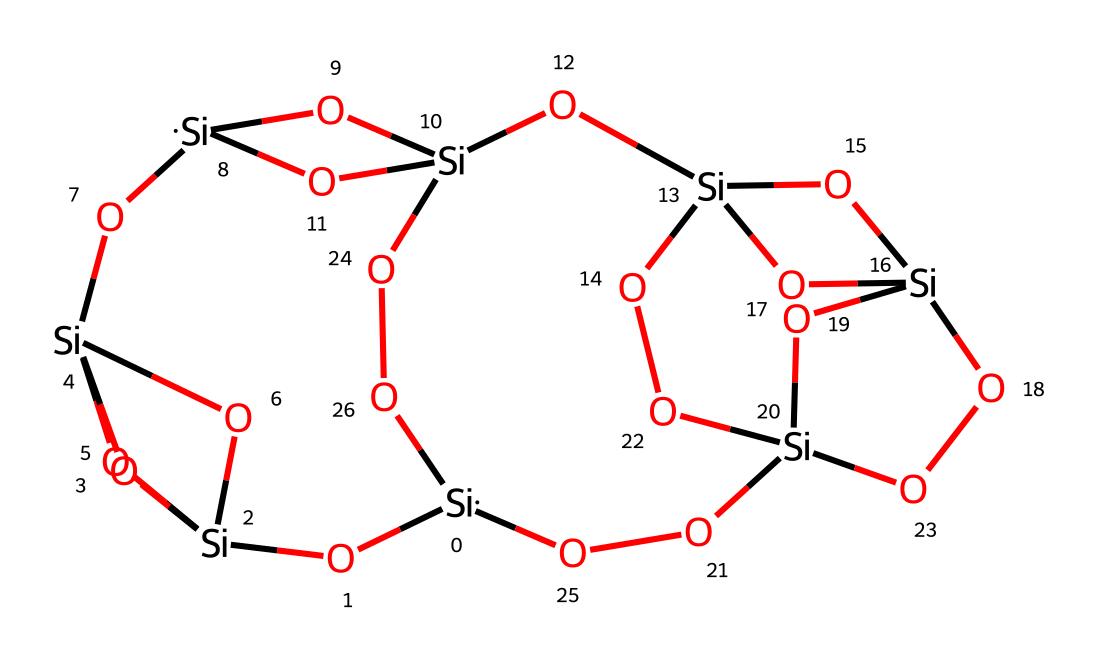what is the total number of silicon atoms in this structure? By examining the SMILES representation, we can count the number of silicon atoms represented by "Si". In the provided SMILES, there are four distinct occurrences of "Si", indicating a total of four silicon atoms.
Answer: four how many oxygen atoms are present in this chemical? The SMILES representation shows "O" appearing multiple times. By counting all occurrences of "O", we find there are eleven oxygen atoms linked within the structure.
Answer: eleven what type of chemical is this compound classified as? The presence of silicon (Si) and oxygen (O) in the formula suggests this is a silsesquioxane. These structures are specifically based on silane chemistry where silicate frameworks are formed.
Answer: silsesquioxane how many hydroxyl (OH) groups are present in the structure? Hydroxyl groups can be identified by the presence of "O" immediately followed by another atom or implied hydrogen. By analyzing the structure closely, there are six hydroxyl groups based on the positioning of oxygen atoms in relation to silicon.
Answer: six which part of the structure suggests its potential for controlled-release drug delivery? The branched nature of the silsesquioxane allows for encapsulation of drug molecules within its structure, as the silicate framework creating voids can retain drugs. The connectivity and branching also imply functionalization capability, which enhances drug release.
Answer: branched silicate framework what is the role of the silicon atoms in this compound? Silicon atoms are central to the silsesquioxane structure, serving as the core framework that connects the various oxygen atoms and hydroxyl groups. They form a network that maintains stability and can interact with drug molecules for controlled release.
Answer: core framework how does the structure indicate the possibility of forming a gel or porous material? The interconnected silicon-oxygen framework allows for flexibility and organization in the compound, which can lead to the formation of a gel-like or porous network, facilitating specific drug release profiles in pulmonary medications.
Answer: interconnected silicon-oxygen framework 